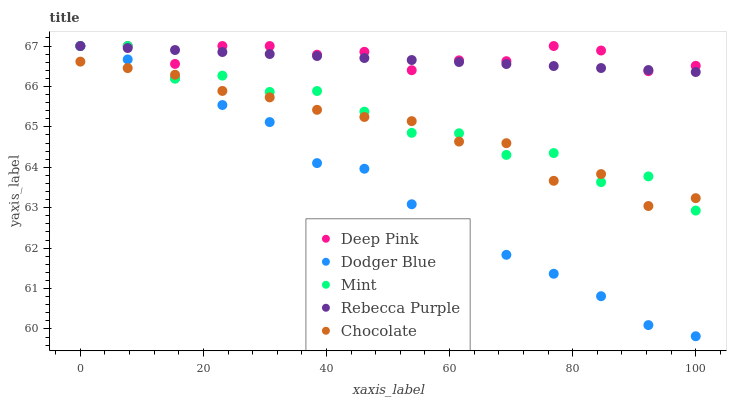Does Dodger Blue have the minimum area under the curve?
Answer yes or no. Yes. Does Deep Pink have the maximum area under the curve?
Answer yes or no. Yes. Does Deep Pink have the minimum area under the curve?
Answer yes or no. No. Does Dodger Blue have the maximum area under the curve?
Answer yes or no. No. Is Rebecca Purple the smoothest?
Answer yes or no. Yes. Is Mint the roughest?
Answer yes or no. Yes. Is Deep Pink the smoothest?
Answer yes or no. No. Is Deep Pink the roughest?
Answer yes or no. No. Does Dodger Blue have the lowest value?
Answer yes or no. Yes. Does Deep Pink have the lowest value?
Answer yes or no. No. Does Rebecca Purple have the highest value?
Answer yes or no. Yes. Does Chocolate have the highest value?
Answer yes or no. No. Is Chocolate less than Rebecca Purple?
Answer yes or no. Yes. Is Rebecca Purple greater than Chocolate?
Answer yes or no. Yes. Does Mint intersect Dodger Blue?
Answer yes or no. Yes. Is Mint less than Dodger Blue?
Answer yes or no. No. Is Mint greater than Dodger Blue?
Answer yes or no. No. Does Chocolate intersect Rebecca Purple?
Answer yes or no. No. 